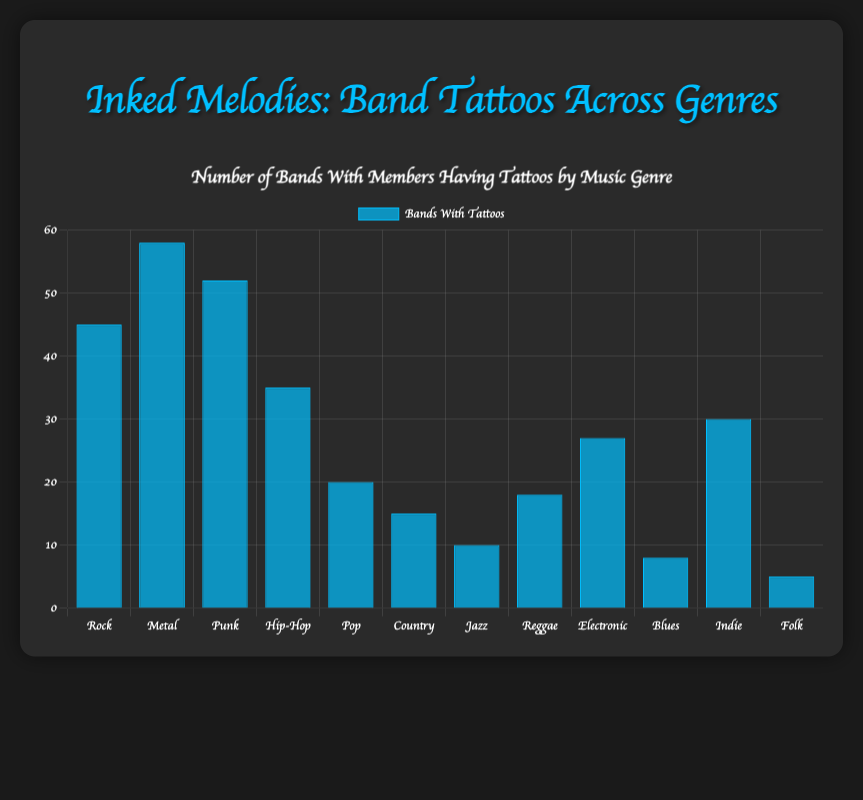What genre has the highest number of bands with members having tattoos? Look at the height of the bars in the chart. The bar representing the 'Metal' genre is the tallest, indicating that it has the highest number of bands with tattoos (58).
Answer: Metal Which genre has fewer bands with members having tattoos: Pop or Country? Compare the heights of the bars for 'Pop' and 'Country'. The 'Country' bar is shorter (15) compared to the 'Pop' bar (20), indicating that 'Country' has fewer bands with members having tattoos.
Answer: Country How many more bands with members having tattoos does the Rock genre have than the Jazz genre? Subtract the number of bands with tattoos in 'Jazz' (10) from those in 'Rock' (45): 45 - 10 = 35.
Answer: 35 What is the average number of bands with tattoos across all genres? Sum all bands with tattoos (45 + 58 + 52 + 35 + 20 + 15 + 10 + 18 + 27 + 8 + 30 + 5) = 323, then divide by the number of genres (12). The average is 323 / 12 ≈ 26.92.
Answer: 26.92 Which three genres have the lowest numbers of bands with members having tattoos? Identify the bars with the smallest heights and note the corresponding genres: 'Folk' (5), 'Blues' (8), and 'Jazz' (10).
Answer: Folk, Blues, Jazz What is the total number of bands with tattoos in the genres Pop, Country, and Blues combined? Add the numbers for 'Pop' (20), 'Country' (15), and 'Blues' (8): 20 + 15 + 8 = 43.
Answer: Pop How does the number of bands with tattoos in the Electronic genre compare to the Indie genre? Compare the bars for 'Electronic' (27) and 'Indie' (30). The 'Indie' bar is slightly taller, indicating more bands with tattoos in the 'Indie' genre than 'Electronic'.
Answer: Indie Which genre shows a number of bands with tattoos closest to the average number of bands with tattoos across all genres? The average number of bands with tattoos is approximately 26.9. Compare each genre to find the closest: 'Pop' (20), 'Electric' (27). The 'Electronic' genre (27) is the closest (only 0.1 difference).
Answer: Electronic Which genres have a number of bands with members having tattoos greater than 50? Check the height of the bars to find those greater than 50. 'Metal' (58) and 'Punk' (52) are the only genres that meet this criterion.
Answer: Metal, Punk 